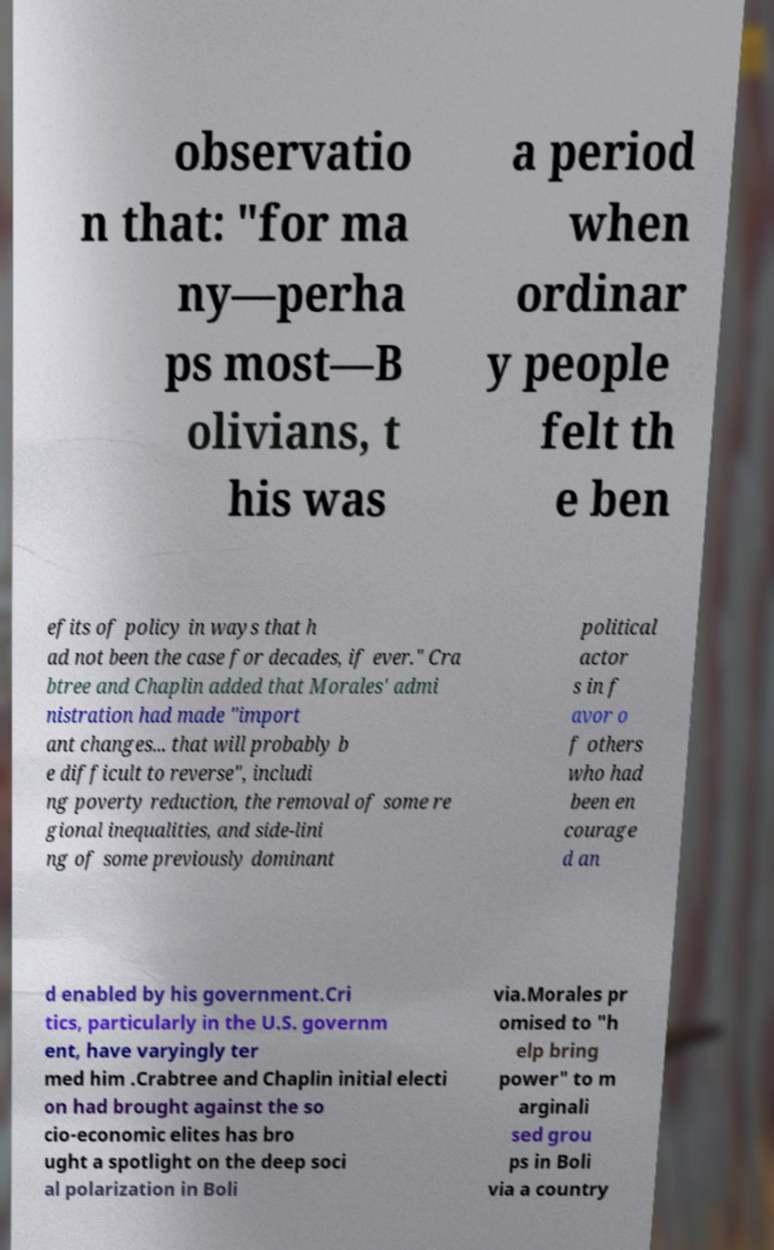What messages or text are displayed in this image? I need them in a readable, typed format. observatio n that: "for ma ny—perha ps most—B olivians, t his was a period when ordinar y people felt th e ben efits of policy in ways that h ad not been the case for decades, if ever." Cra btree and Chaplin added that Morales' admi nistration had made "import ant changes... that will probably b e difficult to reverse", includi ng poverty reduction, the removal of some re gional inequalities, and side-lini ng of some previously dominant political actor s in f avor o f others who had been en courage d an d enabled by his government.Cri tics, particularly in the U.S. governm ent, have varyingly ter med him .Crabtree and Chaplin initial electi on had brought against the so cio-economic elites has bro ught a spotlight on the deep soci al polarization in Boli via.Morales pr omised to "h elp bring power" to m arginali sed grou ps in Boli via a country 